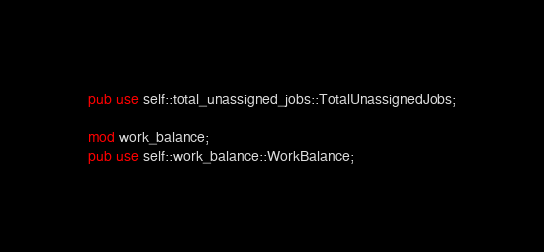<code> <loc_0><loc_0><loc_500><loc_500><_Rust_>pub use self::total_unassigned_jobs::TotalUnassignedJobs;

mod work_balance;
pub use self::work_balance::WorkBalance;
</code> 